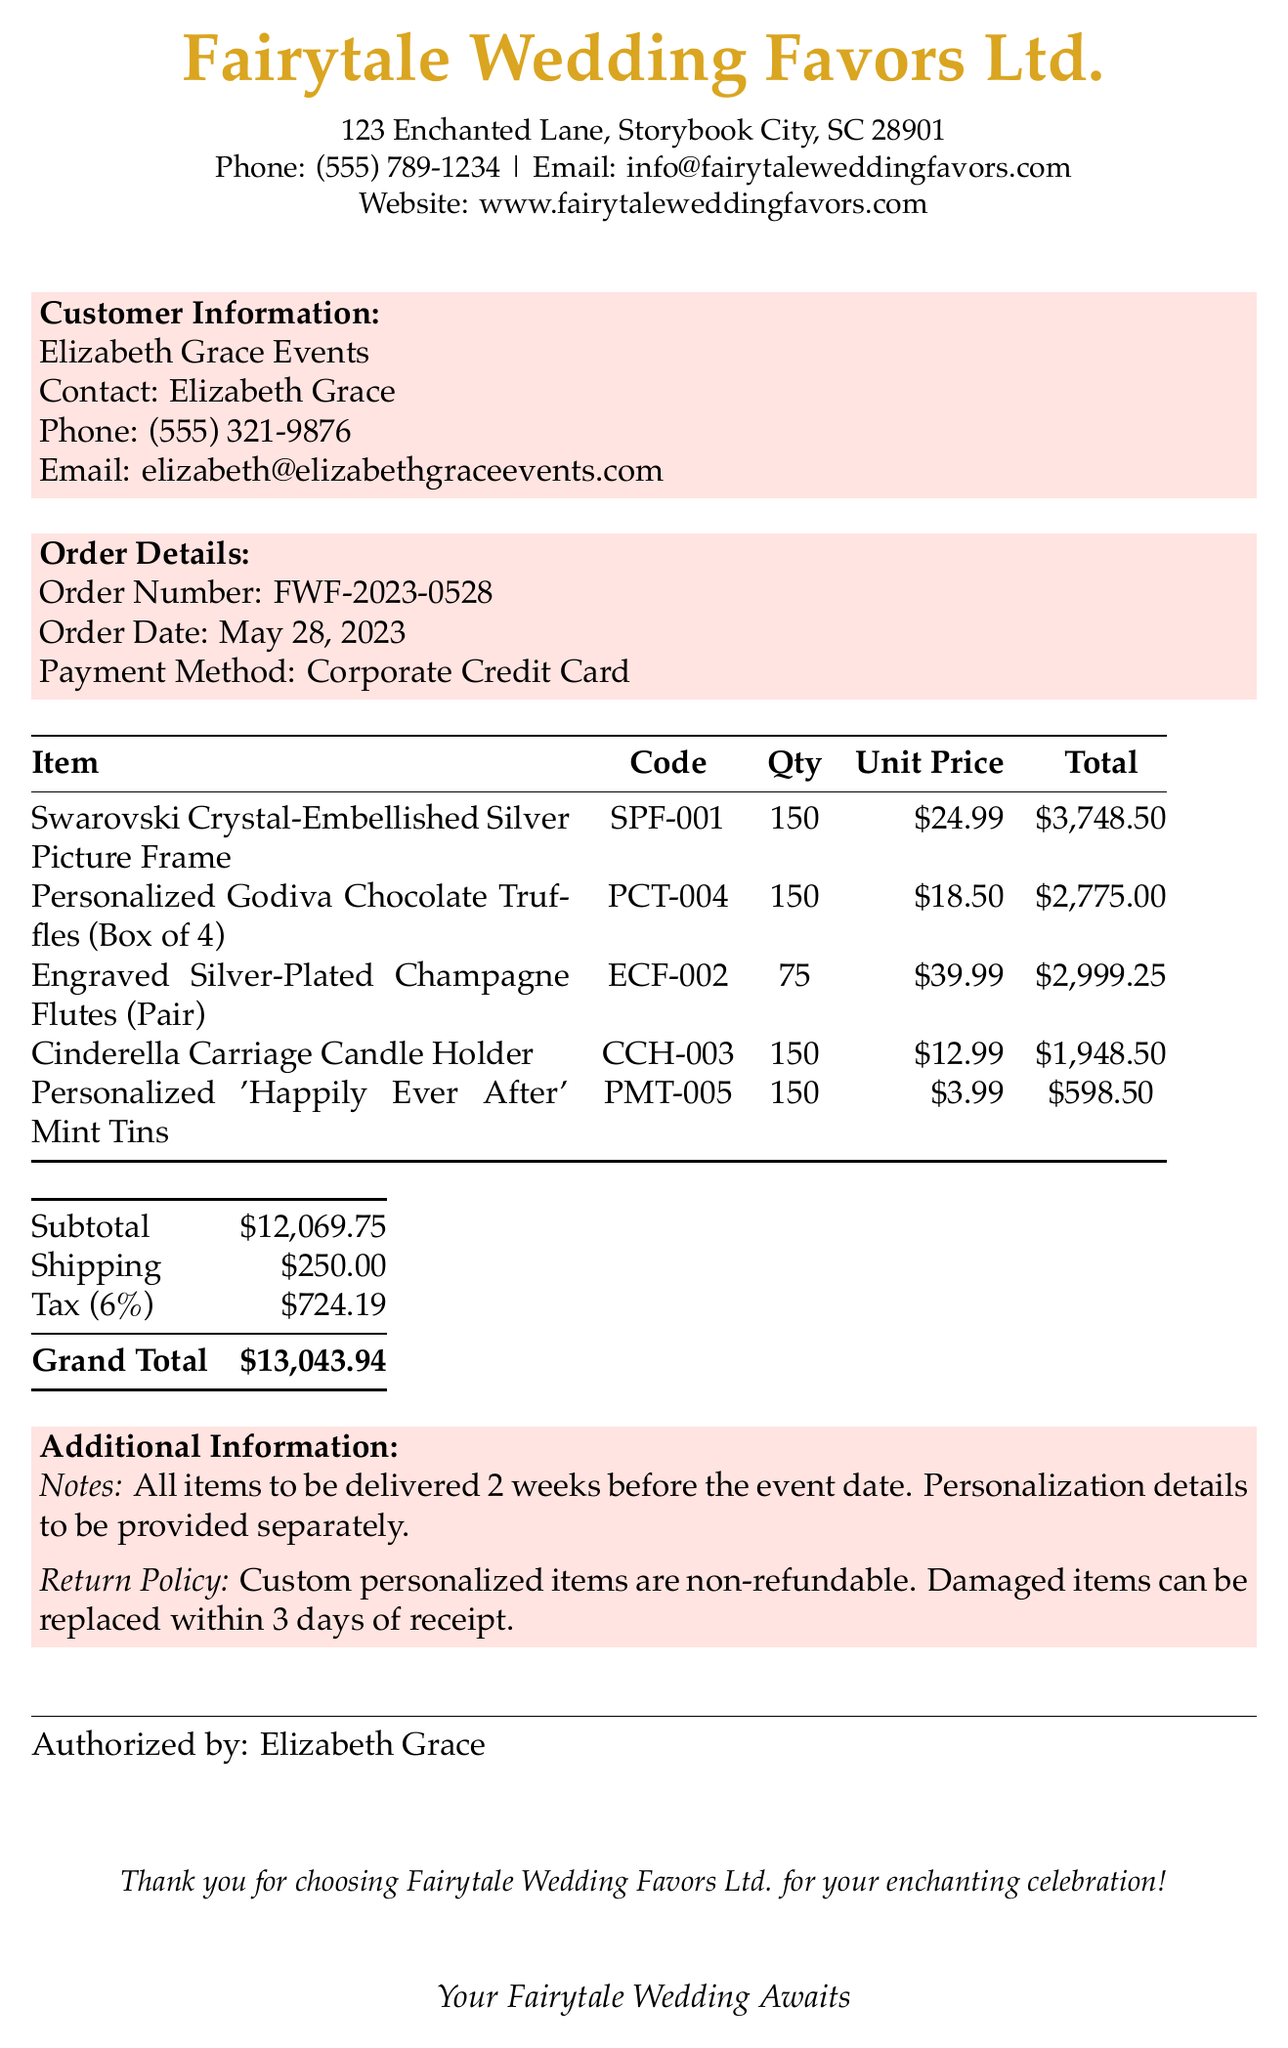What is the company name? The company name is listed at the top of the receipt as Fairytale Wedding Favors Ltd.
Answer: Fairytale Wedding Favors Ltd What is the order date? The order date is specified in the order details section of the receipt.
Answer: May 28, 2023 How many personalized chocolates were ordered? The quantity of personalized chocolates is detailed in the items section of the receipt.
Answer: 150 What is the grand total amount? The grand total is calculated based on the subtotal, shipping, and tax amounts listed on the receipt.
Answer: $13,043.94 What is the return policy for custom items? The return policy is given in the additional information section, stating the terms for personalized items.
Answer: Custom personalized items are non-refundable What item has the highest unit price? The item with the highest unit price can be determined by comparing all unit prices in the items table.
Answer: Engraved Silver-Plated Champagne Flutes (Pair) What is the subtotal before tax? The subtotal is the total of all item prices before any additional charges, listed specifically in the receipt.
Answer: $12,069.75 What is included in the customer information section? The customer information section provides the name and contact details of the purchasing entity.
Answer: Elizabeth Grace Events What is the shipping cost? The shipping cost is explicitly stated in the total charges section of the receipt.
Answer: $250.00 